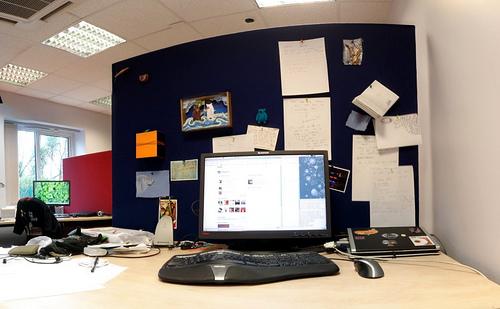Is the monitor on?
Give a very brief answer. Yes. What colors are the walls?
Concise answer only. White. What hand would the person operating this computer use to operate the mouse?
Quick response, please. Right. 